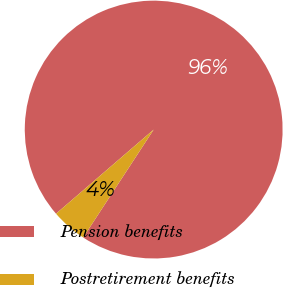Convert chart to OTSL. <chart><loc_0><loc_0><loc_500><loc_500><pie_chart><fcel>Pension benefits<fcel>Postretirement benefits<nl><fcel>95.53%<fcel>4.47%<nl></chart> 